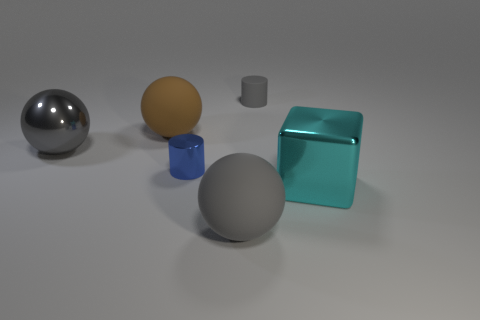Add 3 matte balls. How many objects exist? 9 Subtract all cubes. How many objects are left? 5 Add 3 big matte balls. How many big matte balls exist? 5 Subtract 0 cyan balls. How many objects are left? 6 Subtract all brown rubber objects. Subtract all cyan blocks. How many objects are left? 4 Add 4 big brown matte objects. How many big brown matte objects are left? 5 